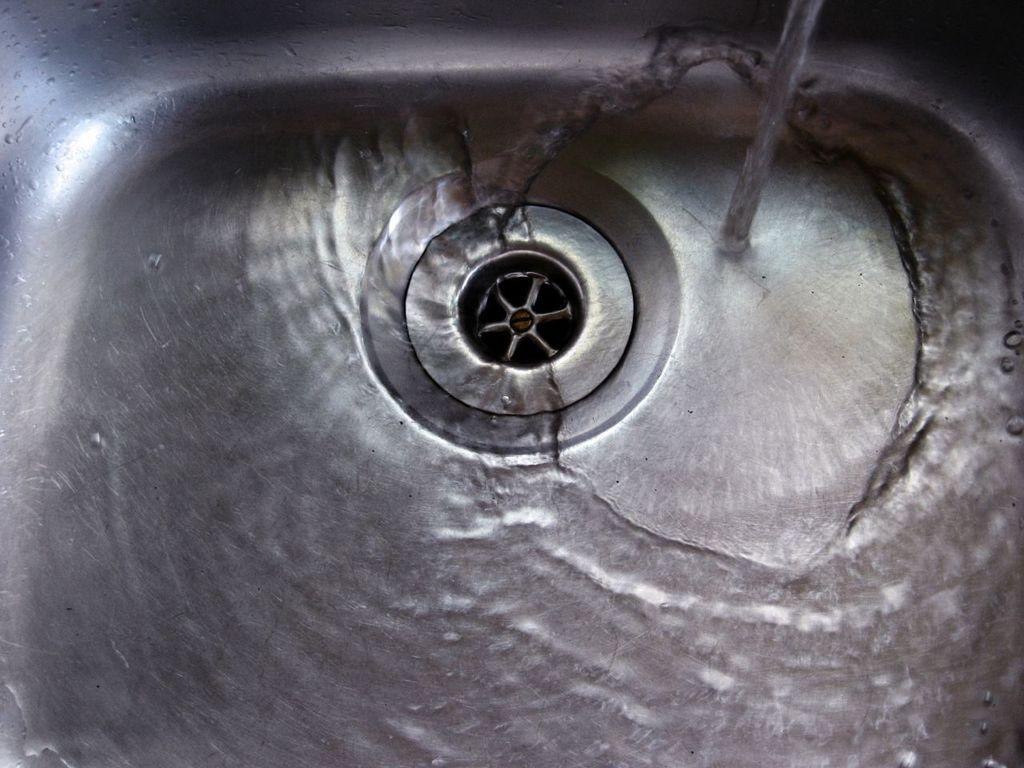Please provide a concise description of this image. The picture consists of a sink, in the sink there is water. At the top there is water flowing. 